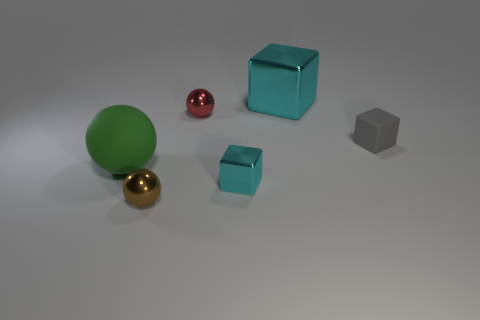Do the big cube and the small shiny cube have the same color?
Make the answer very short. Yes. What color is the large object that is the same shape as the small gray rubber thing?
Give a very brief answer. Cyan. What is the cyan cube behind the cyan metallic cube in front of the big green rubber ball made of?
Offer a very short reply. Metal. There is a cyan shiny thing that is on the left side of the large cyan cube; is its shape the same as the big thing that is behind the small red metal thing?
Offer a terse response. Yes. What size is the shiny object that is both to the left of the tiny cyan block and in front of the large green object?
Provide a succinct answer. Small. What number of other things are there of the same color as the big block?
Keep it short and to the point. 1. Do the large thing on the left side of the tiny red ball and the large cyan cube have the same material?
Provide a short and direct response. No. Are there any other things that are the same size as the rubber block?
Your answer should be very brief. Yes. Is the number of large cyan things in front of the large metallic object less than the number of tiny red spheres right of the rubber ball?
Give a very brief answer. Yes. Are there any other things that are the same shape as the red shiny thing?
Offer a terse response. Yes. 